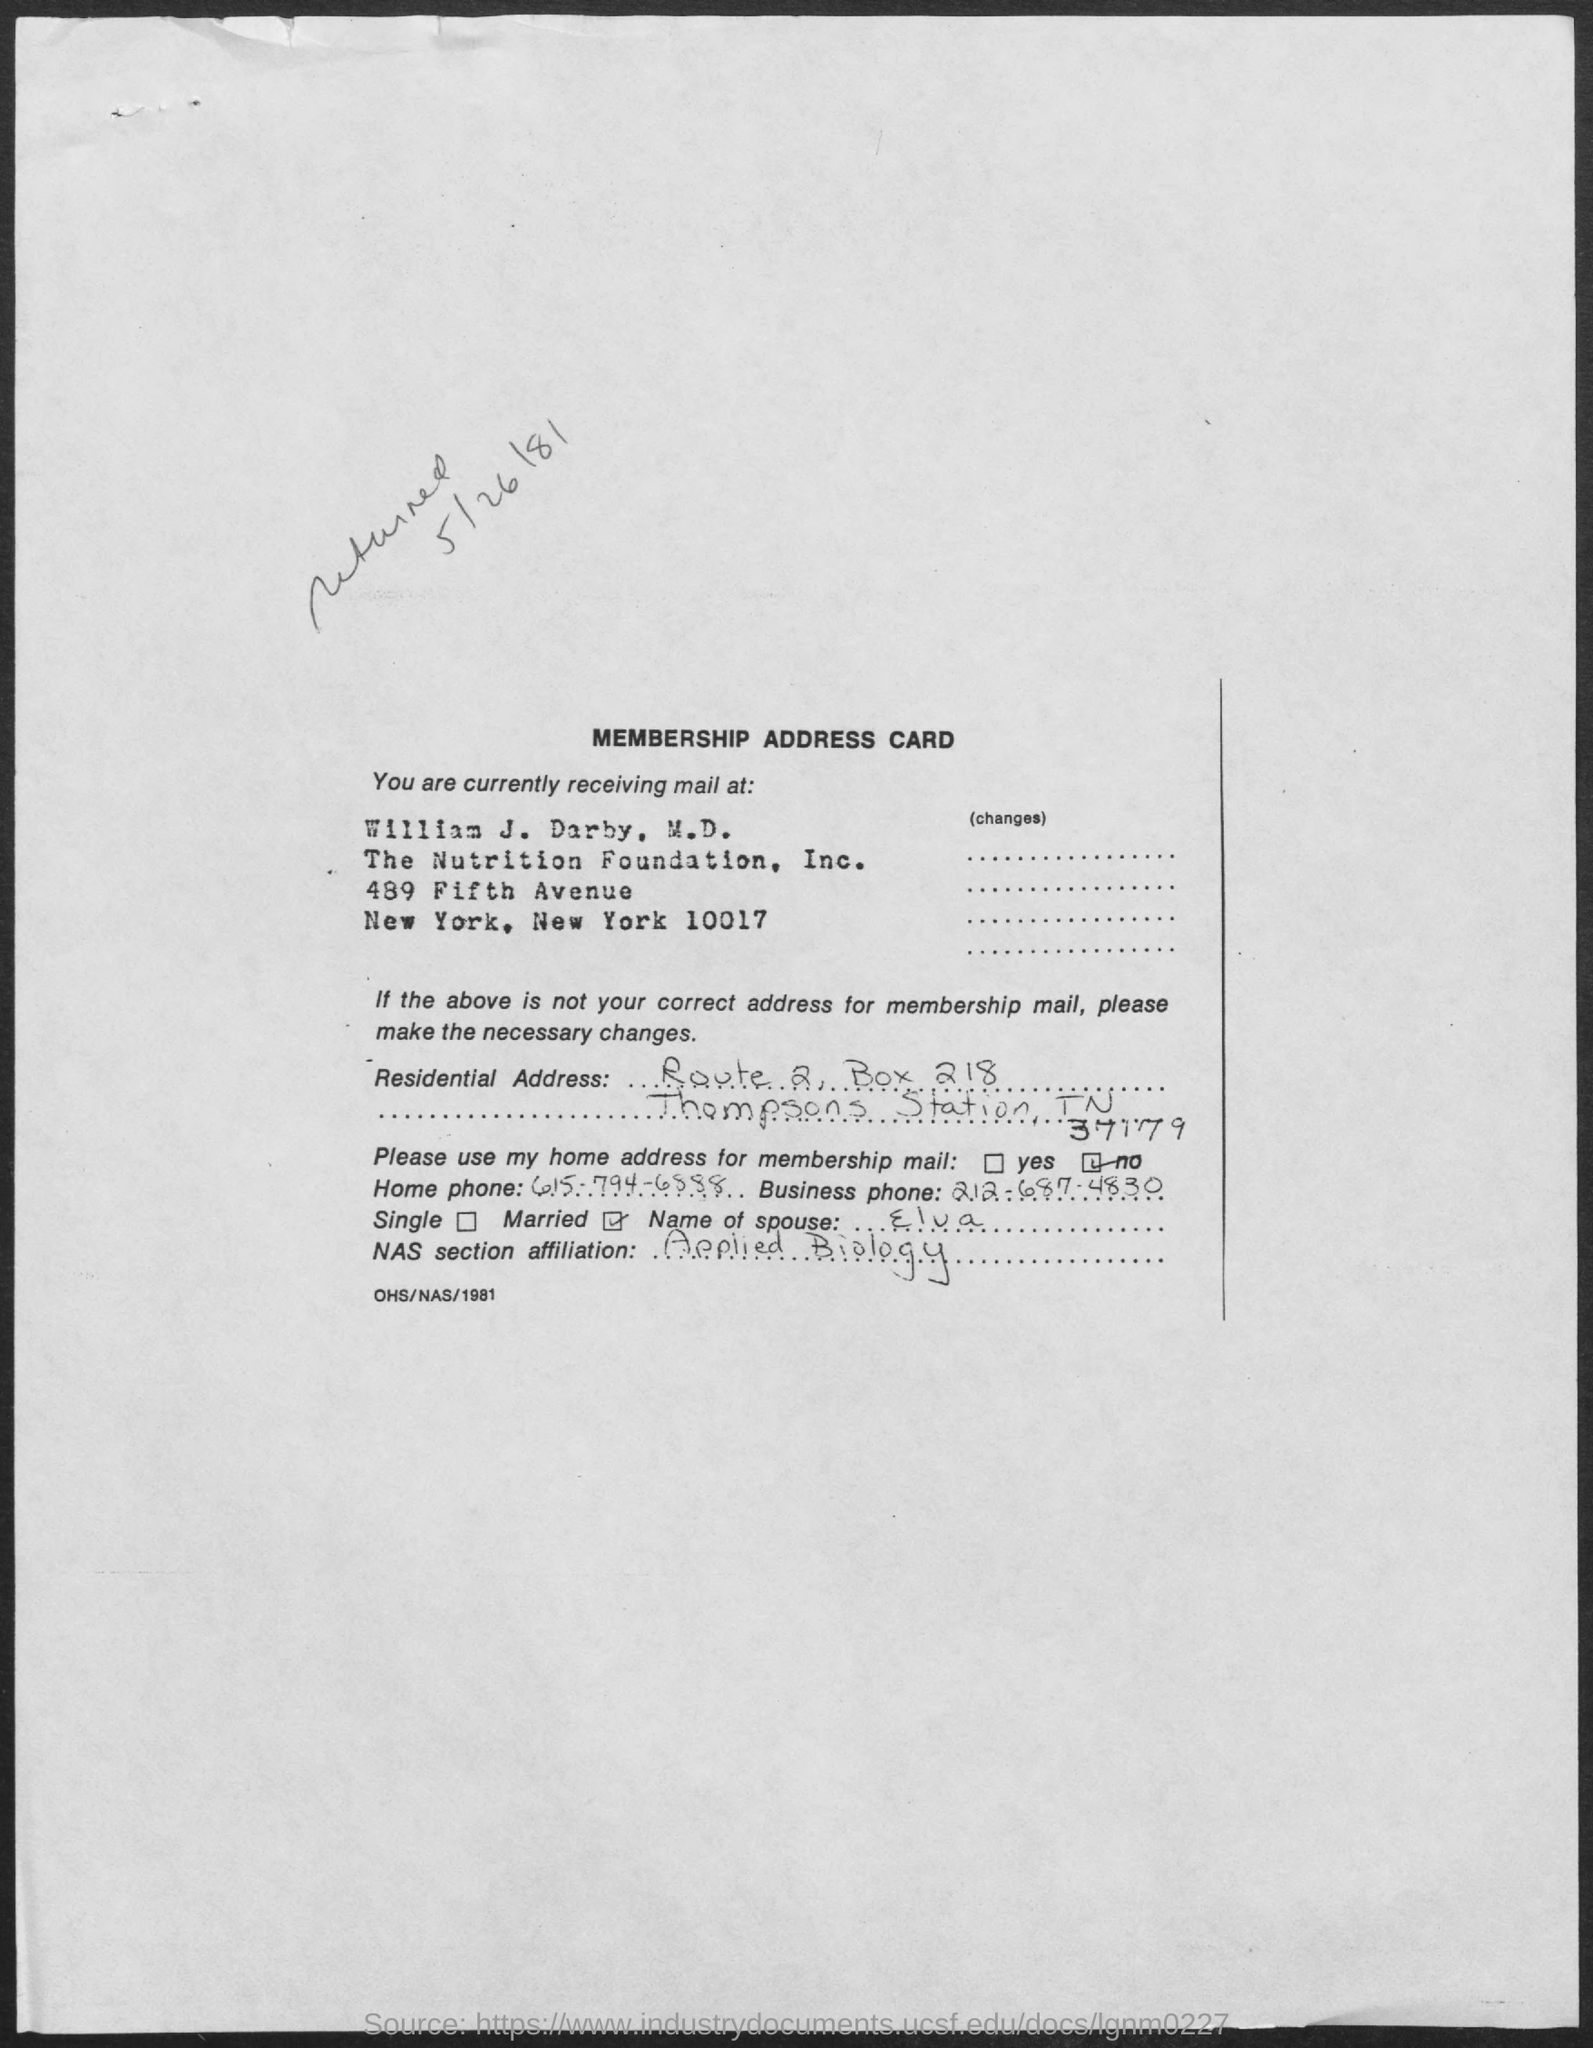What is the name of the foundation mentioned ?
Ensure brevity in your answer.  The nutrition foundation. What is the box no. mentioned ?
Keep it short and to the point. 218. What is the name of the spouse mentioned ?
Your response must be concise. Elva. What is the business phone mentioned?
Keep it short and to the point. 212-687-4830. What is the home phone no. mentioned ?
Make the answer very short. 615-794-6888. What is the nas section affiliation mentioned in the given document ?
Your answer should be very brief. Applied biology. 